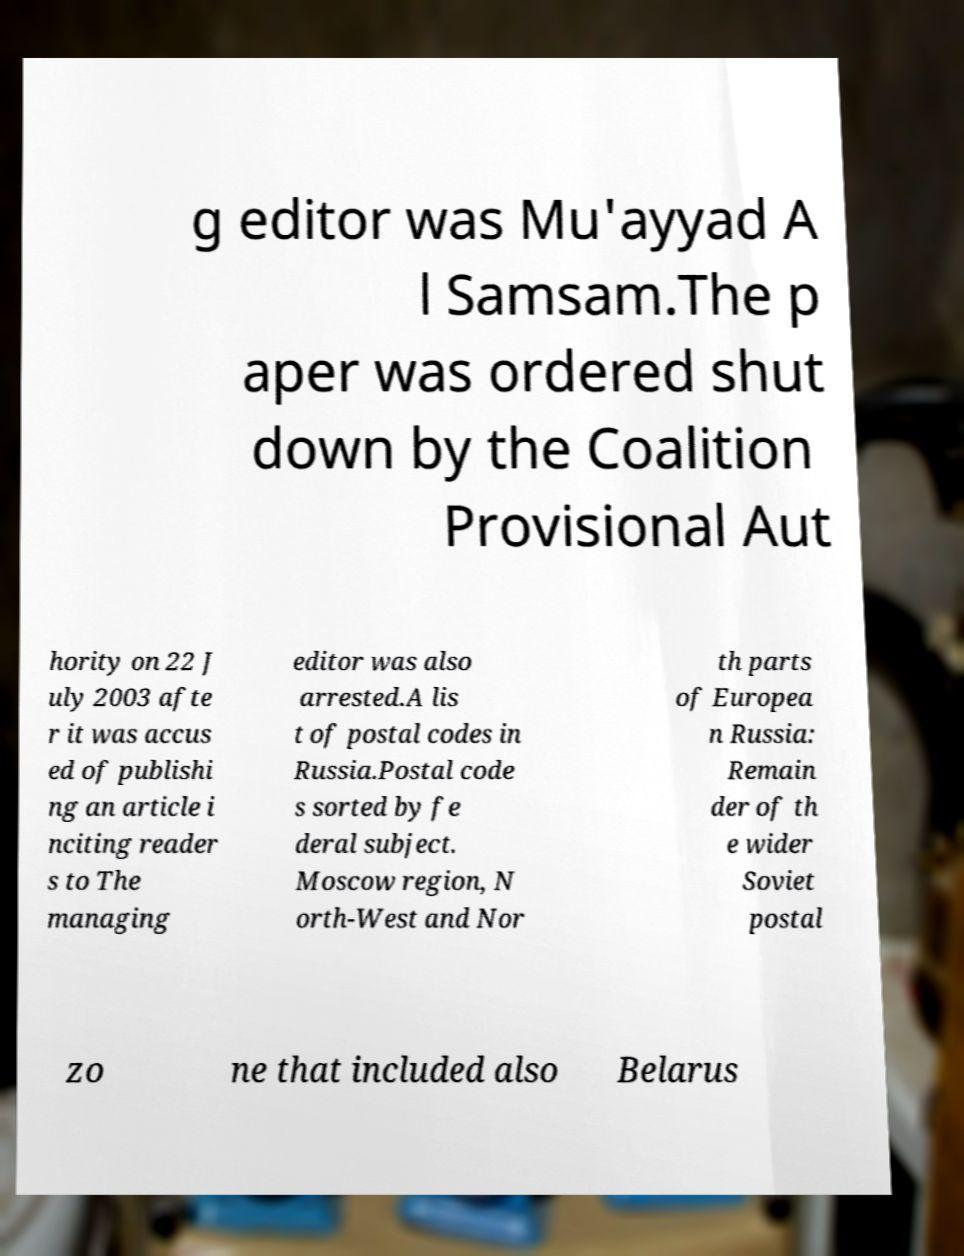I need the written content from this picture converted into text. Can you do that? g editor was Mu'ayyad A l Samsam.The p aper was ordered shut down by the Coalition Provisional Aut hority on 22 J uly 2003 afte r it was accus ed of publishi ng an article i nciting reader s to The managing editor was also arrested.A lis t of postal codes in Russia.Postal code s sorted by fe deral subject. Moscow region, N orth-West and Nor th parts of Europea n Russia: Remain der of th e wider Soviet postal zo ne that included also Belarus 